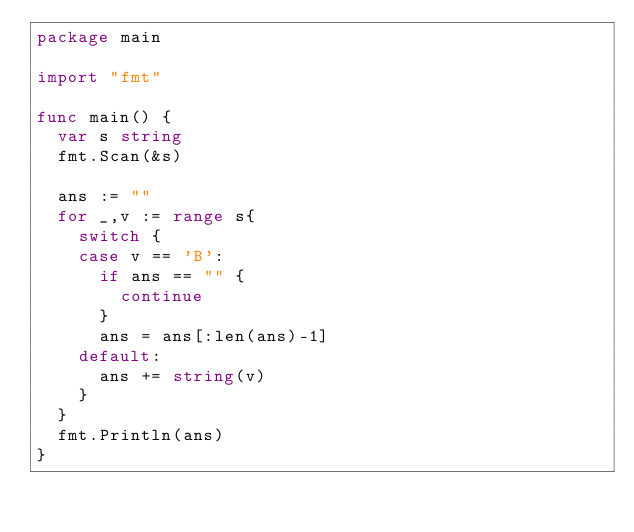<code> <loc_0><loc_0><loc_500><loc_500><_Go_>package main

import "fmt"

func main() {
	var s string
	fmt.Scan(&s)

	ans := ""
	for _,v := range s{
		switch {
		case v == 'B':
			if ans == "" {
				continue
			}
			ans = ans[:len(ans)-1]
		default:
			ans += string(v)
		}
	}
	fmt.Println(ans)
}
</code> 